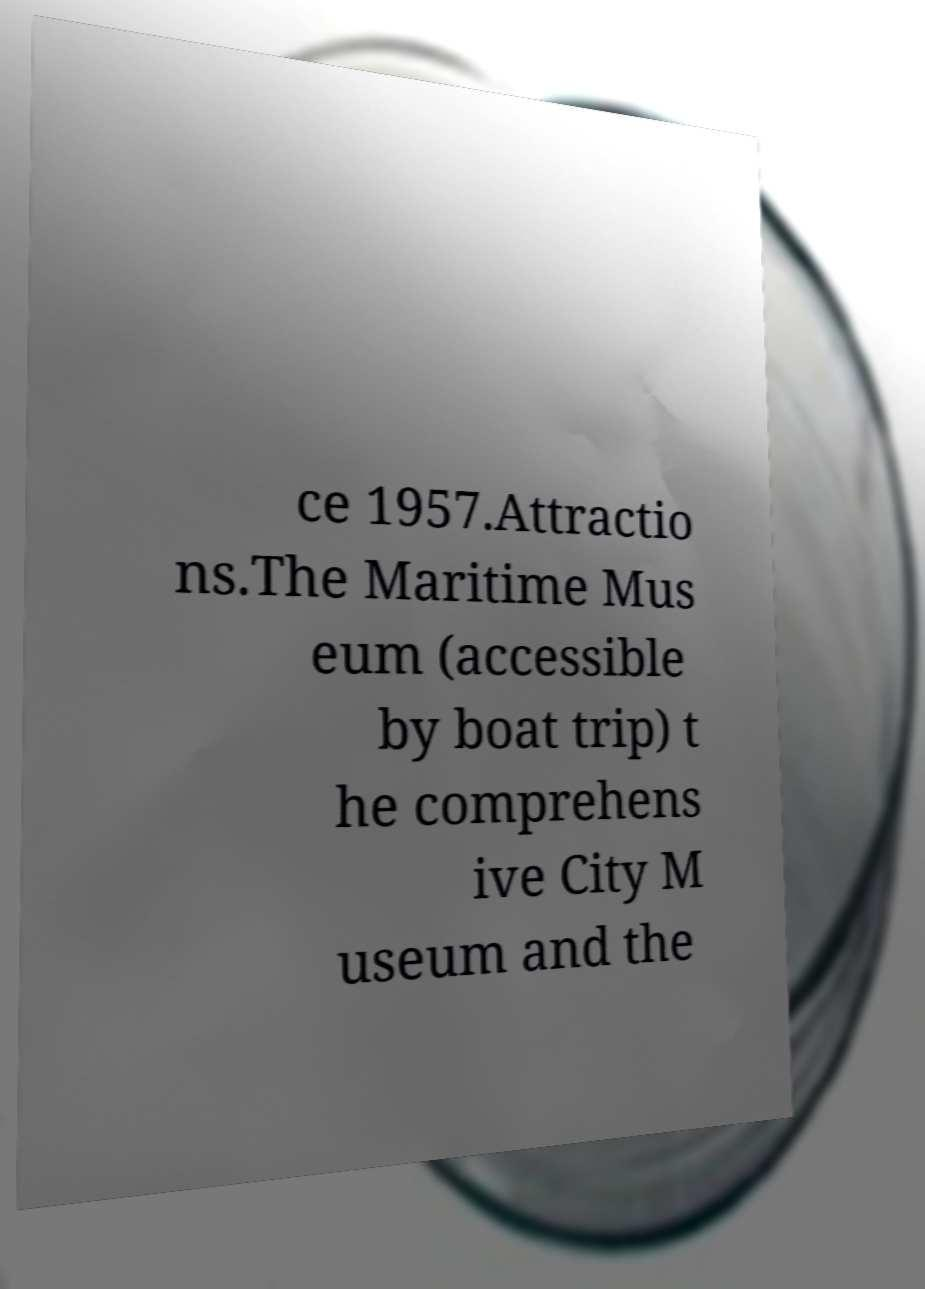Please read and relay the text visible in this image. What does it say? ce 1957.Attractio ns.The Maritime Mus eum (accessible by boat trip) t he comprehens ive City M useum and the 